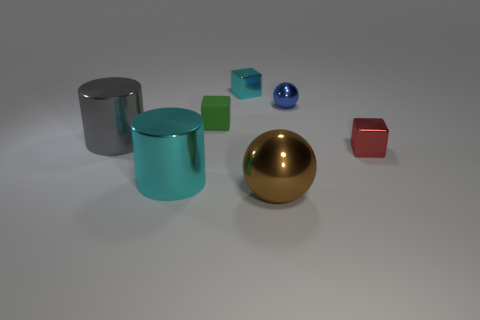Add 3 big brown metal cylinders. How many objects exist? 10 Subtract all spheres. How many objects are left? 5 Subtract all big brown matte cylinders. Subtract all big things. How many objects are left? 4 Add 2 large brown things. How many large brown things are left? 3 Add 5 big metal objects. How many big metal objects exist? 8 Subtract 0 blue cylinders. How many objects are left? 7 